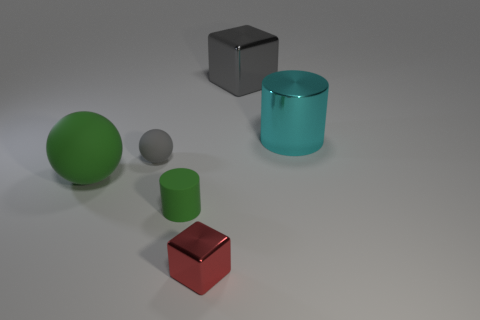Add 2 gray blocks. How many objects exist? 8 Subtract all cylinders. How many objects are left? 4 Add 5 metallic objects. How many metallic objects are left? 8 Add 3 red metallic cubes. How many red metallic cubes exist? 4 Subtract 0 purple cylinders. How many objects are left? 6 Subtract all cylinders. Subtract all purple metallic cylinders. How many objects are left? 4 